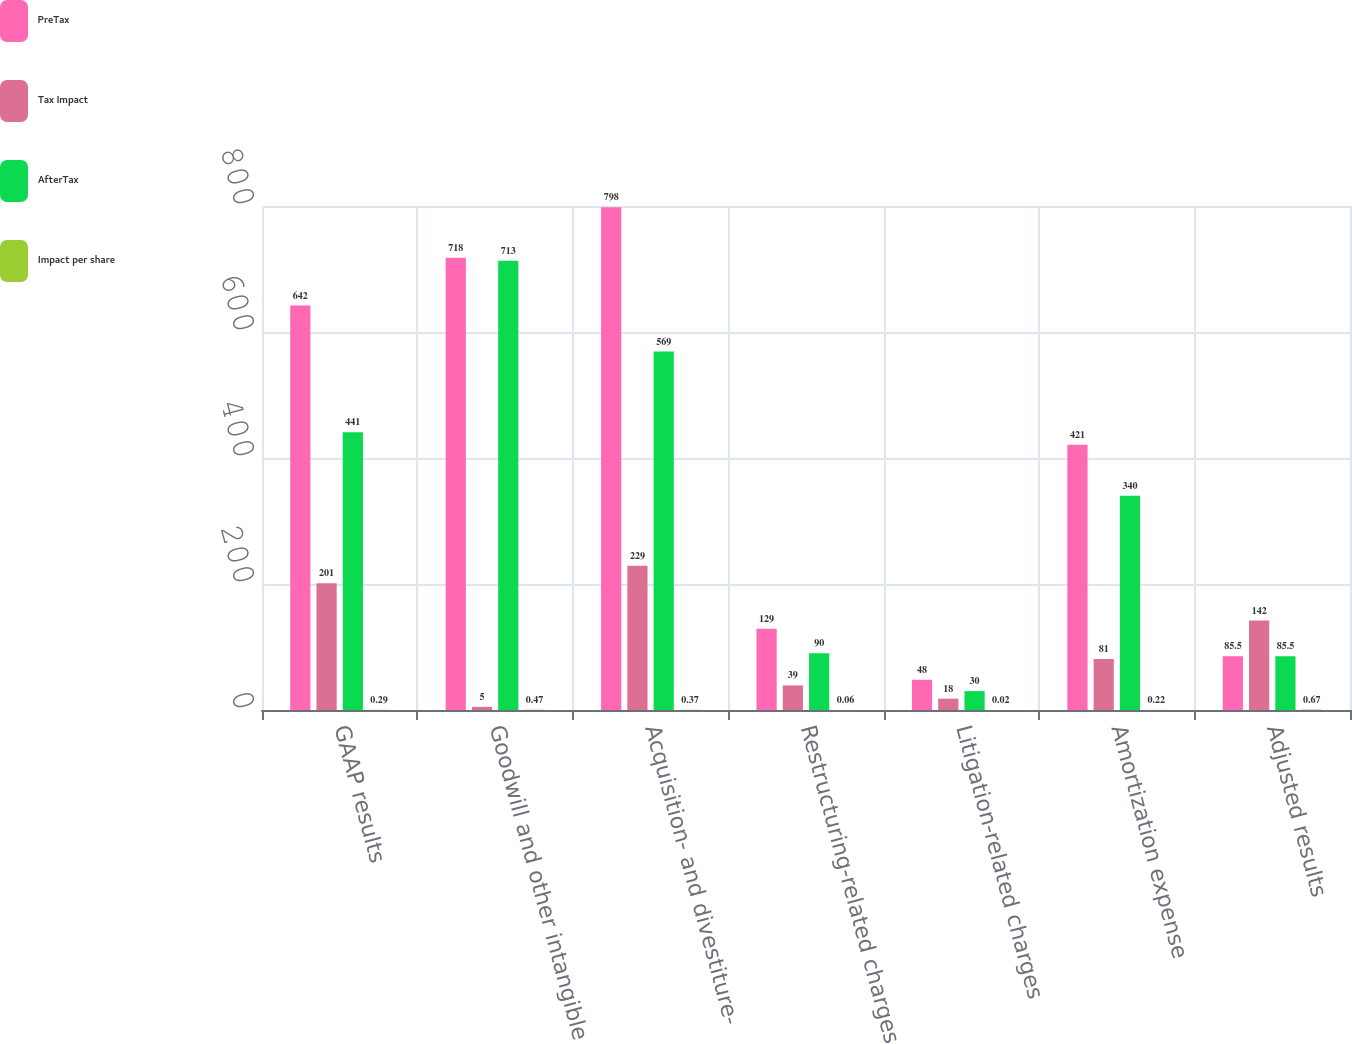Convert chart to OTSL. <chart><loc_0><loc_0><loc_500><loc_500><stacked_bar_chart><ecel><fcel>GAAP results<fcel>Goodwill and other intangible<fcel>Acquisition- and divestiture-<fcel>Restructuring-related charges<fcel>Litigation-related charges<fcel>Amortization expense<fcel>Adjusted results<nl><fcel>PreTax<fcel>642<fcel>718<fcel>798<fcel>129<fcel>48<fcel>421<fcel>85.5<nl><fcel>Tax Impact<fcel>201<fcel>5<fcel>229<fcel>39<fcel>18<fcel>81<fcel>142<nl><fcel>AfterTax<fcel>441<fcel>713<fcel>569<fcel>90<fcel>30<fcel>340<fcel>85.5<nl><fcel>Impact per share<fcel>0.29<fcel>0.47<fcel>0.37<fcel>0.06<fcel>0.02<fcel>0.22<fcel>0.67<nl></chart> 